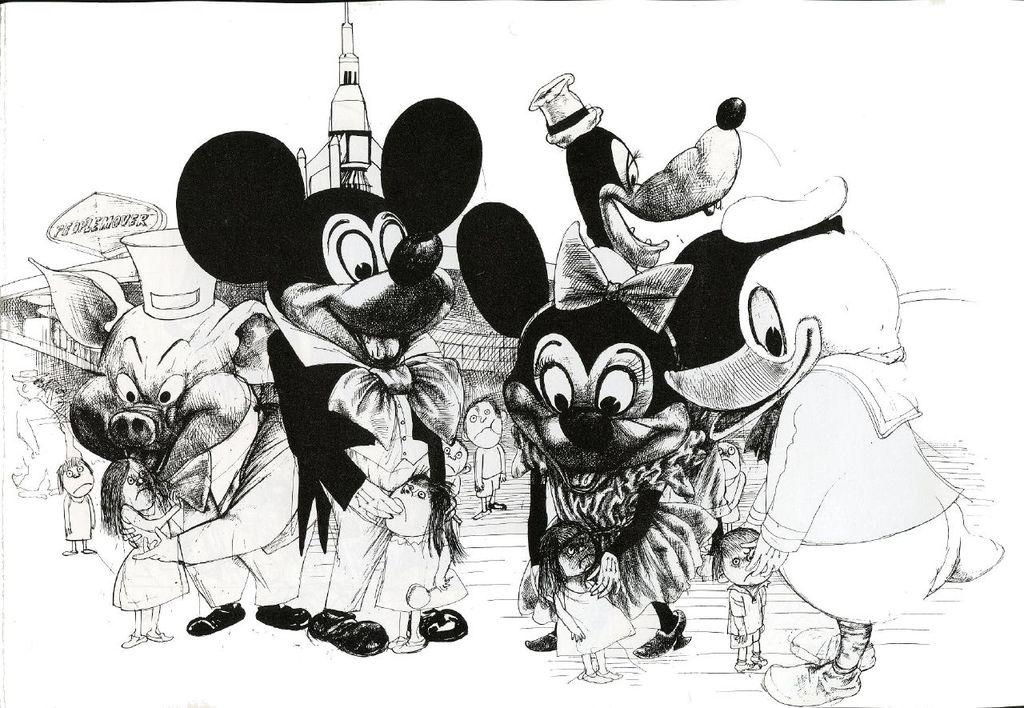What type of images are in the picture? There are cartoon images in the picture. Can you identify any specific character in the picture? Yes, Mickey Mouse is present in the picture. What is Mickey Mouse doing in the picture? Mickey Mouse is holding a girl in the picture. What can be seen in the background of the picture? There is a building visible in the background. Are there any other characters besides Mickey Mouse in the picture? Yes, a duck and a pig are present in the picture. What type of sponge is being used to clean the nation in the picture? There is no sponge or nation present in the picture; it features cartoon images of Mickey Mouse, a girl, a duck, and a pig. 